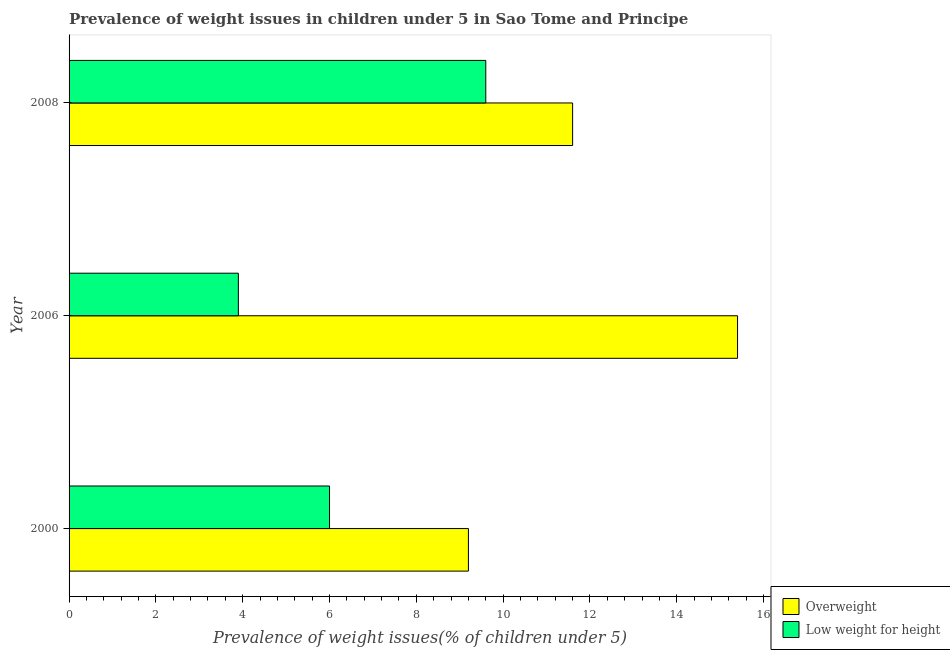Are the number of bars per tick equal to the number of legend labels?
Your response must be concise. Yes. Are the number of bars on each tick of the Y-axis equal?
Give a very brief answer. Yes. What is the percentage of overweight children in 2008?
Offer a very short reply. 11.6. Across all years, what is the maximum percentage of underweight children?
Provide a short and direct response. 9.6. Across all years, what is the minimum percentage of underweight children?
Offer a terse response. 3.9. In which year was the percentage of overweight children maximum?
Provide a succinct answer. 2006. What is the total percentage of underweight children in the graph?
Keep it short and to the point. 19.5. What is the difference between the percentage of underweight children in 2000 and that in 2008?
Offer a terse response. -3.6. What is the difference between the percentage of overweight children in 2006 and the percentage of underweight children in 2008?
Provide a succinct answer. 5.8. What is the average percentage of overweight children per year?
Ensure brevity in your answer.  12.07. What is the ratio of the percentage of underweight children in 2000 to that in 2008?
Offer a terse response. 0.62. Is the difference between the percentage of overweight children in 2006 and 2008 greater than the difference between the percentage of underweight children in 2006 and 2008?
Keep it short and to the point. Yes. What is the difference between the highest and the second highest percentage of overweight children?
Provide a succinct answer. 3.8. What is the difference between the highest and the lowest percentage of overweight children?
Make the answer very short. 6.2. Is the sum of the percentage of underweight children in 2000 and 2006 greater than the maximum percentage of overweight children across all years?
Offer a terse response. No. What does the 1st bar from the top in 2006 represents?
Offer a terse response. Low weight for height. What does the 1st bar from the bottom in 2000 represents?
Provide a succinct answer. Overweight. How many years are there in the graph?
Your answer should be very brief. 3. Where does the legend appear in the graph?
Your response must be concise. Bottom right. How many legend labels are there?
Offer a very short reply. 2. How are the legend labels stacked?
Offer a terse response. Vertical. What is the title of the graph?
Your answer should be very brief. Prevalence of weight issues in children under 5 in Sao Tome and Principe. Does "Foreign liabilities" appear as one of the legend labels in the graph?
Your response must be concise. No. What is the label or title of the X-axis?
Make the answer very short. Prevalence of weight issues(% of children under 5). What is the label or title of the Y-axis?
Make the answer very short. Year. What is the Prevalence of weight issues(% of children under 5) of Overweight in 2000?
Give a very brief answer. 9.2. What is the Prevalence of weight issues(% of children under 5) in Overweight in 2006?
Your answer should be very brief. 15.4. What is the Prevalence of weight issues(% of children under 5) in Low weight for height in 2006?
Offer a terse response. 3.9. What is the Prevalence of weight issues(% of children under 5) in Overweight in 2008?
Your answer should be very brief. 11.6. What is the Prevalence of weight issues(% of children under 5) in Low weight for height in 2008?
Offer a terse response. 9.6. Across all years, what is the maximum Prevalence of weight issues(% of children under 5) of Overweight?
Offer a very short reply. 15.4. Across all years, what is the maximum Prevalence of weight issues(% of children under 5) in Low weight for height?
Offer a very short reply. 9.6. Across all years, what is the minimum Prevalence of weight issues(% of children under 5) in Overweight?
Provide a succinct answer. 9.2. Across all years, what is the minimum Prevalence of weight issues(% of children under 5) of Low weight for height?
Keep it short and to the point. 3.9. What is the total Prevalence of weight issues(% of children under 5) of Overweight in the graph?
Your answer should be compact. 36.2. What is the difference between the Prevalence of weight issues(% of children under 5) in Low weight for height in 2000 and that in 2006?
Your answer should be compact. 2.1. What is the difference between the Prevalence of weight issues(% of children under 5) of Low weight for height in 2000 and that in 2008?
Your answer should be very brief. -3.6. What is the difference between the Prevalence of weight issues(% of children under 5) in Low weight for height in 2006 and that in 2008?
Provide a succinct answer. -5.7. What is the difference between the Prevalence of weight issues(% of children under 5) of Overweight in 2000 and the Prevalence of weight issues(% of children under 5) of Low weight for height in 2006?
Keep it short and to the point. 5.3. What is the difference between the Prevalence of weight issues(% of children under 5) in Overweight in 2000 and the Prevalence of weight issues(% of children under 5) in Low weight for height in 2008?
Your answer should be very brief. -0.4. What is the difference between the Prevalence of weight issues(% of children under 5) in Overweight in 2006 and the Prevalence of weight issues(% of children under 5) in Low weight for height in 2008?
Provide a succinct answer. 5.8. What is the average Prevalence of weight issues(% of children under 5) in Overweight per year?
Make the answer very short. 12.07. What is the average Prevalence of weight issues(% of children under 5) in Low weight for height per year?
Your answer should be very brief. 6.5. In the year 2000, what is the difference between the Prevalence of weight issues(% of children under 5) in Overweight and Prevalence of weight issues(% of children under 5) in Low weight for height?
Your response must be concise. 3.2. In the year 2006, what is the difference between the Prevalence of weight issues(% of children under 5) of Overweight and Prevalence of weight issues(% of children under 5) of Low weight for height?
Provide a succinct answer. 11.5. In the year 2008, what is the difference between the Prevalence of weight issues(% of children under 5) in Overweight and Prevalence of weight issues(% of children under 5) in Low weight for height?
Offer a very short reply. 2. What is the ratio of the Prevalence of weight issues(% of children under 5) in Overweight in 2000 to that in 2006?
Keep it short and to the point. 0.6. What is the ratio of the Prevalence of weight issues(% of children under 5) in Low weight for height in 2000 to that in 2006?
Your answer should be very brief. 1.54. What is the ratio of the Prevalence of weight issues(% of children under 5) in Overweight in 2000 to that in 2008?
Give a very brief answer. 0.79. What is the ratio of the Prevalence of weight issues(% of children under 5) of Overweight in 2006 to that in 2008?
Offer a terse response. 1.33. What is the ratio of the Prevalence of weight issues(% of children under 5) in Low weight for height in 2006 to that in 2008?
Give a very brief answer. 0.41. What is the difference between the highest and the second highest Prevalence of weight issues(% of children under 5) in Low weight for height?
Keep it short and to the point. 3.6. What is the difference between the highest and the lowest Prevalence of weight issues(% of children under 5) of Low weight for height?
Ensure brevity in your answer.  5.7. 